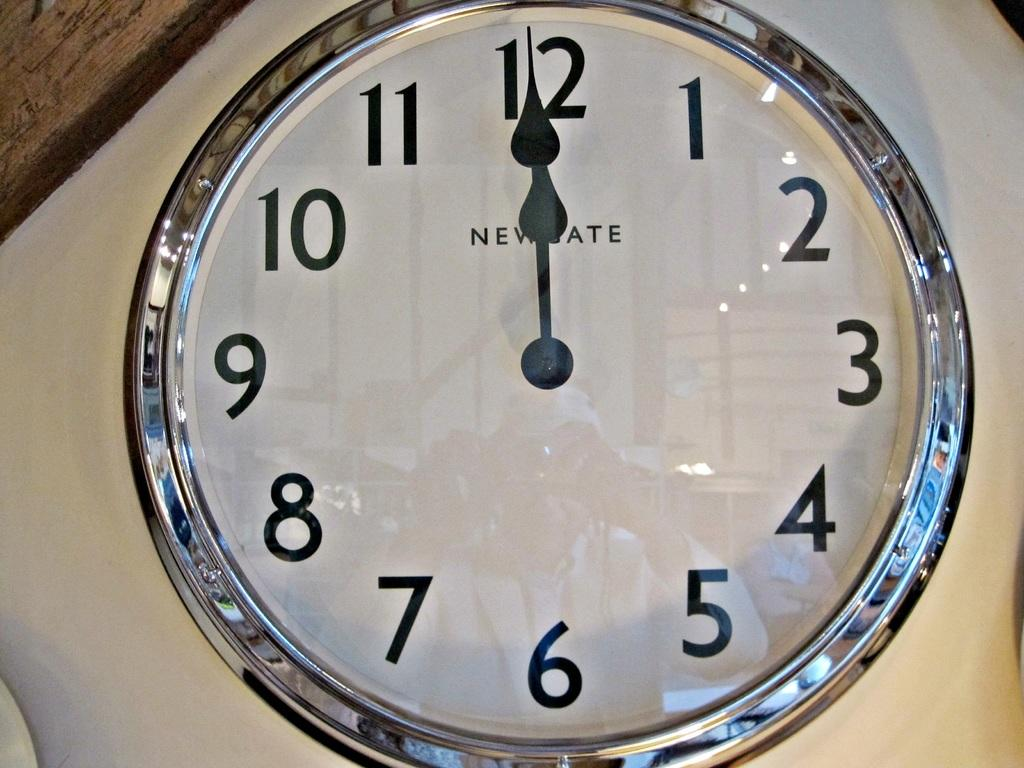<image>
Share a concise interpretation of the image provided. Circular clock which has the hands on 12 and says NEWSTATE. 